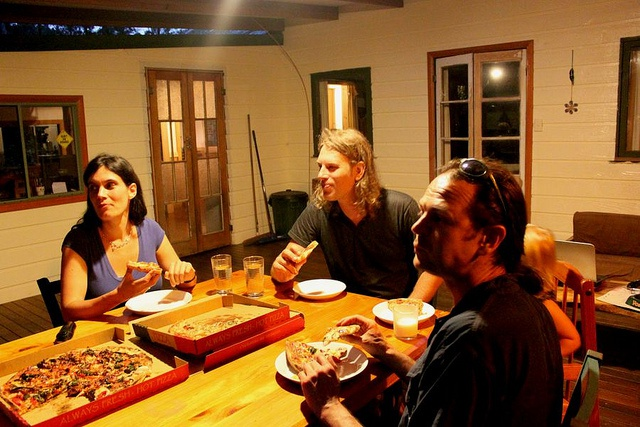Describe the objects in this image and their specific colors. I can see dining table in black, orange, gold, maroon, and red tones, people in black, maroon, and orange tones, people in black, brown, maroon, and red tones, people in black, orange, and maroon tones, and pizza in black, red, orange, brown, and maroon tones in this image. 